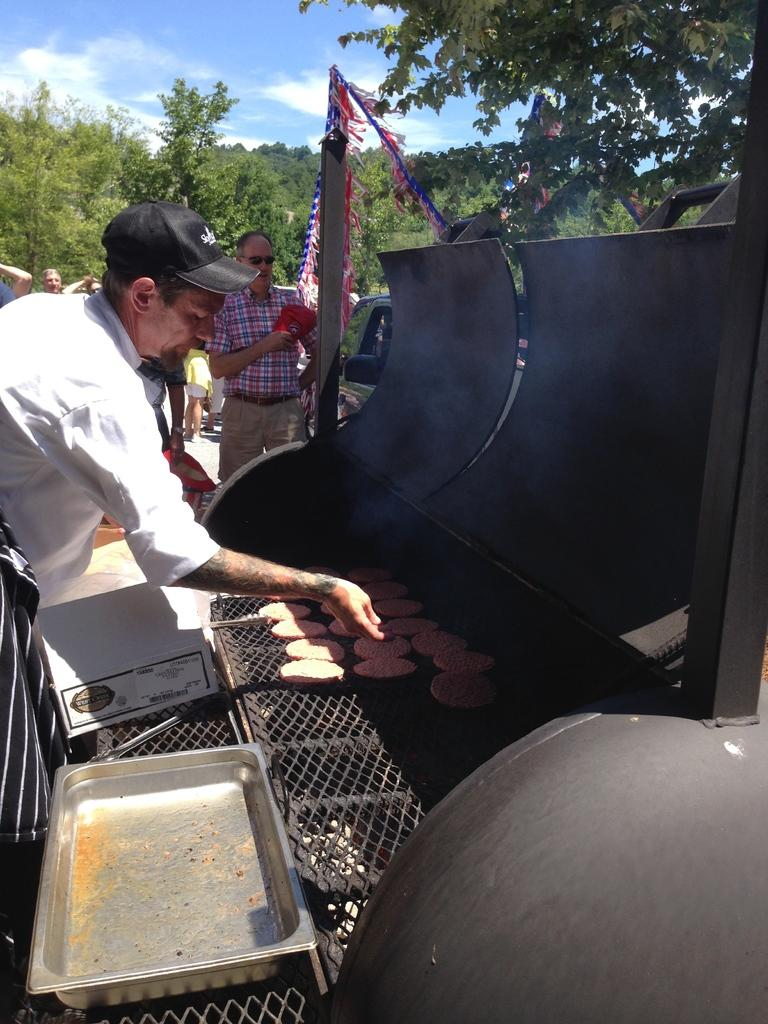What is the person in the image doing? The person in the image is standing and cooking. What can be seen in the background of the image? There are trees, persons, and a car in the background of the image. What is the condition of the sky in the image? The sky is cloudy in the image. What type of wound can be seen on the person's arm in the image? There is no wound visible on the person's arm in the image. What sound might the alarm make in the image? There is no alarm present in the image, so it is not possible to determine what sound it might make. 